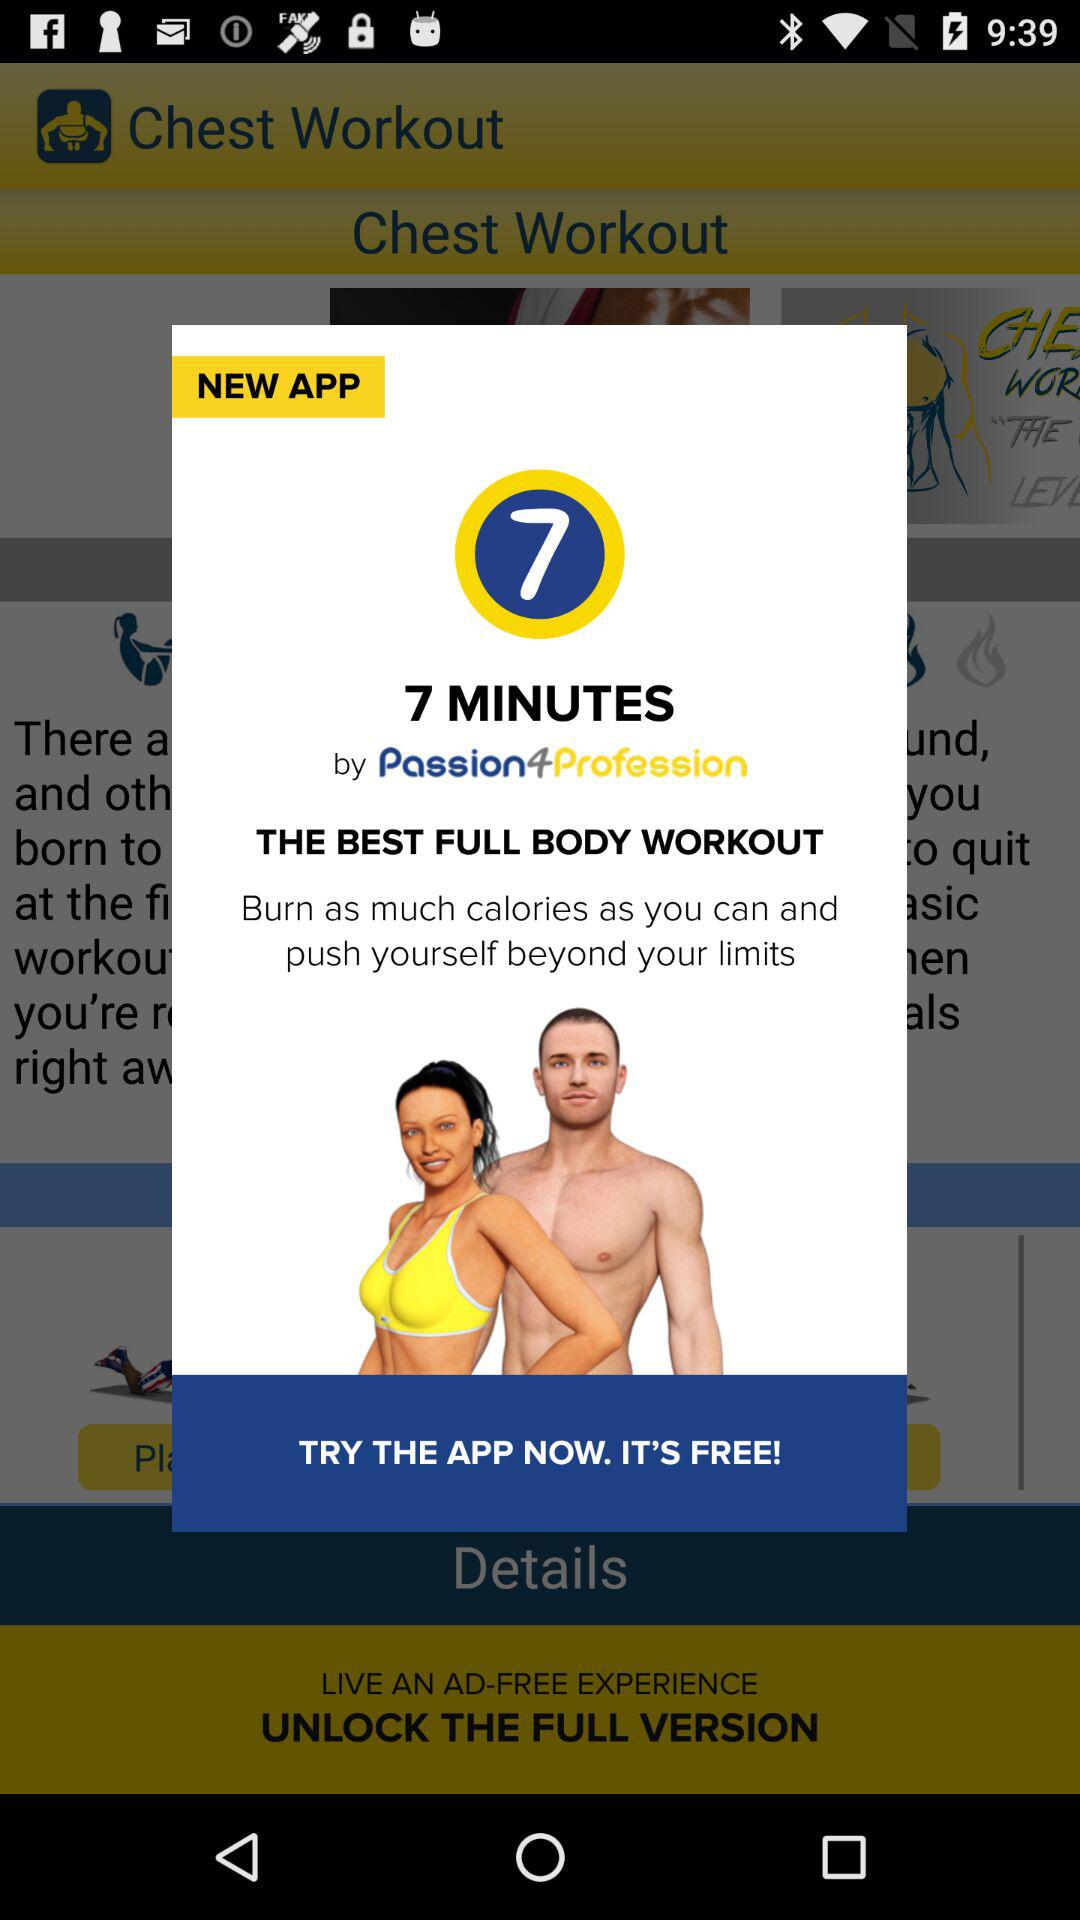Is the app free or paid? The app is free. 